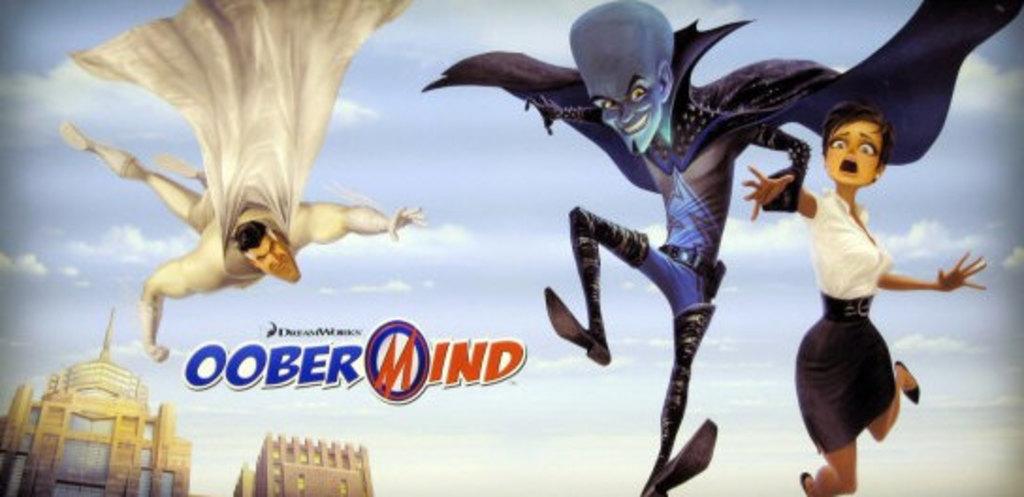What is the title?
Ensure brevity in your answer.  Oobermind. What word is in red?
Your response must be concise. Mind. 